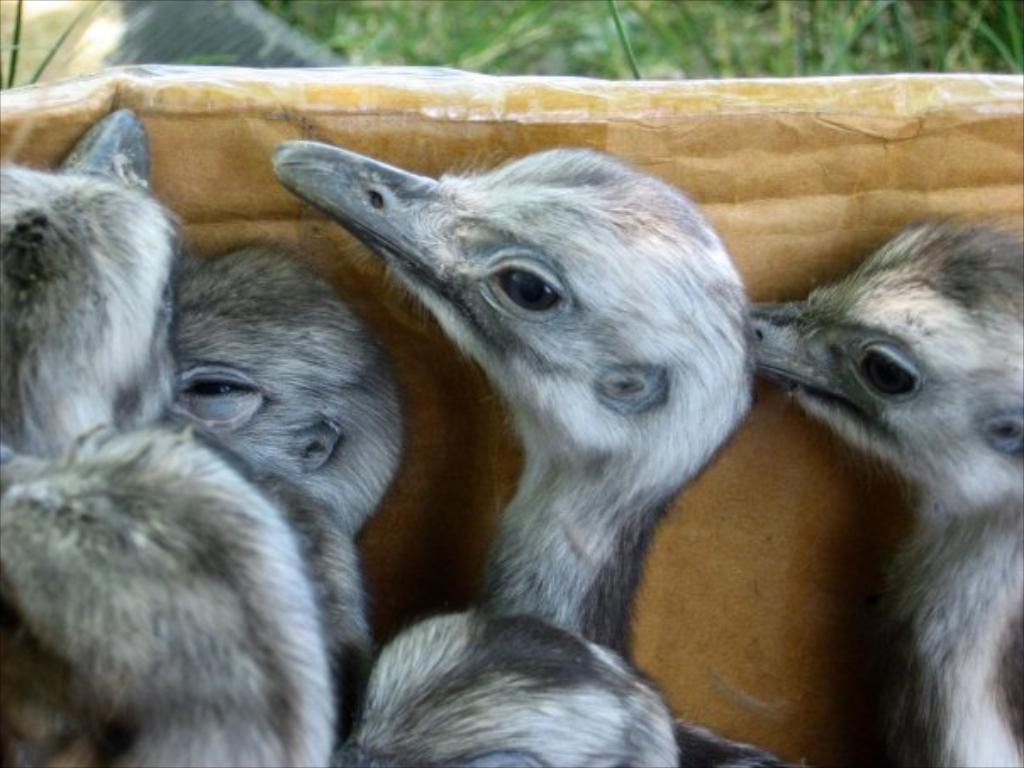What type of animals are present in the image? There are duck babies in the image. Where are the duck babies located? The duck babies are in a closed environment. Can you describe the background of the image? The background of the image is blurry. What color is the sister's scarf in the image? There is no sister or scarf present in the image. 